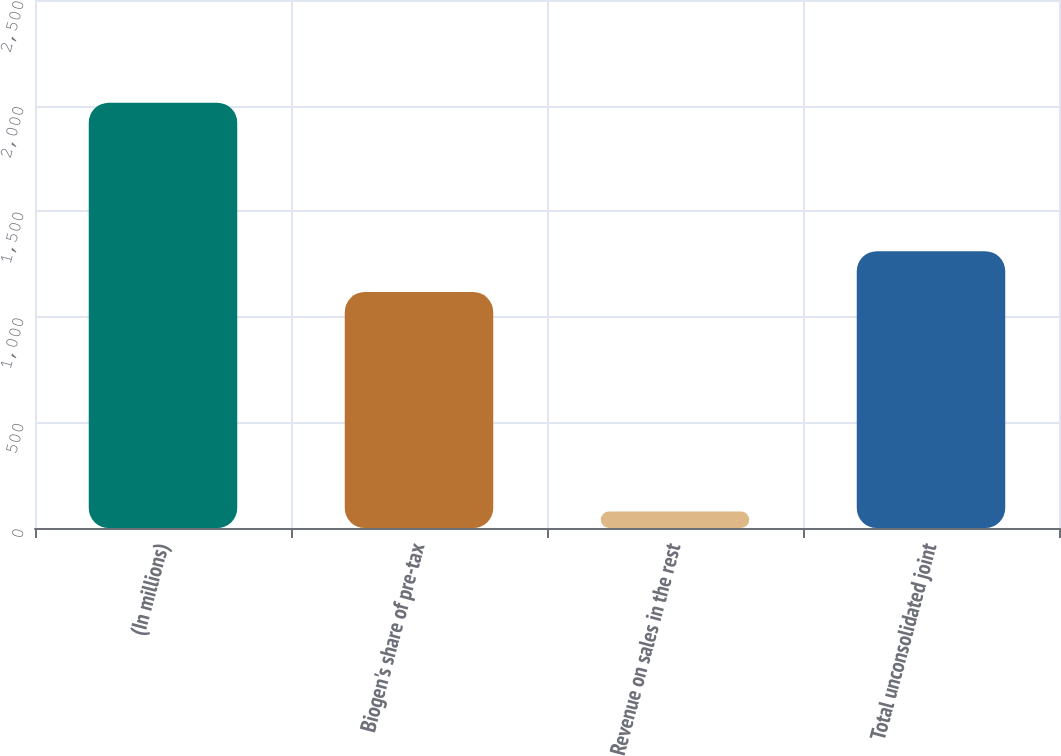Convert chart to OTSL. <chart><loc_0><loc_0><loc_500><loc_500><bar_chart><fcel>(In millions)<fcel>Biogen's share of pre-tax<fcel>Revenue on sales in the rest<fcel>Total unconsolidated joint<nl><fcel>2014<fcel>1117.1<fcel>78.3<fcel>1310.67<nl></chart> 